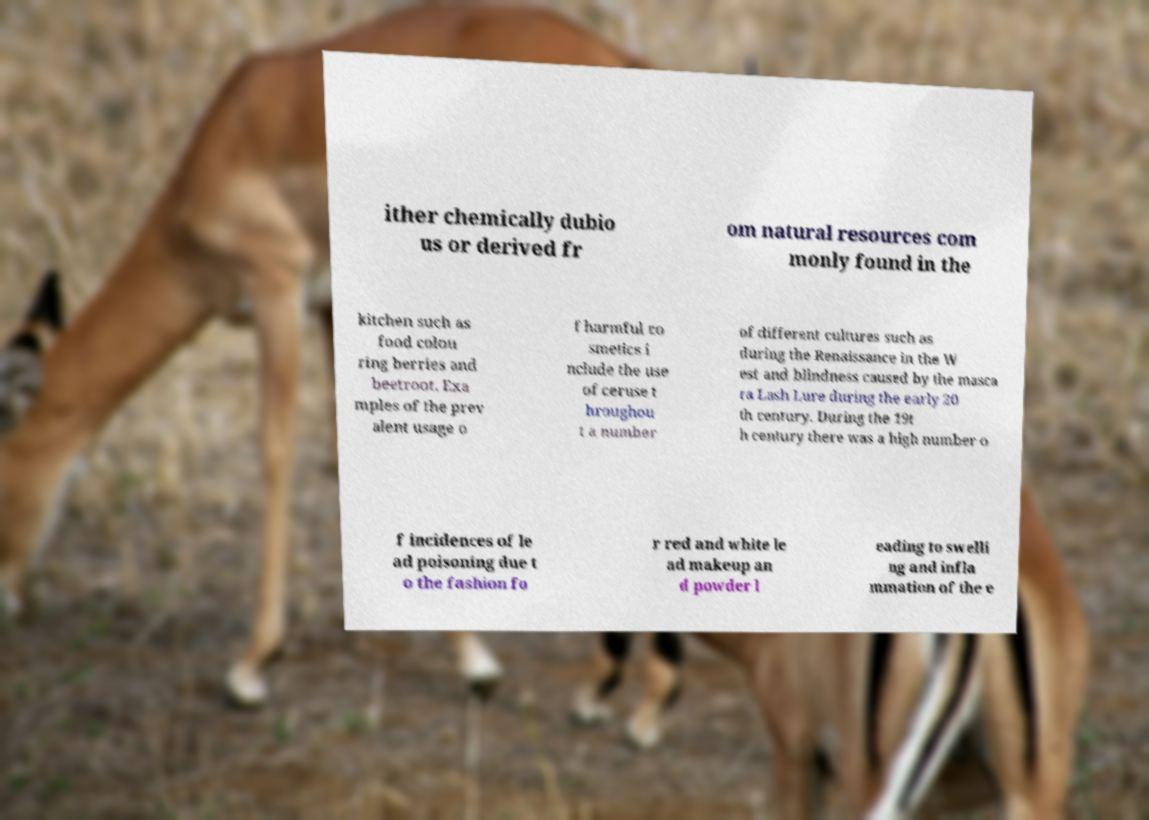Can you accurately transcribe the text from the provided image for me? ither chemically dubio us or derived fr om natural resources com monly found in the kitchen such as food colou ring berries and beetroot. Exa mples of the prev alent usage o f harmful co smetics i nclude the use of ceruse t hroughou t a number of different cultures such as during the Renaissance in the W est and blindness caused by the masca ra Lash Lure during the early 20 th century. During the 19t h century there was a high number o f incidences of le ad poisoning due t o the fashion fo r red and white le ad makeup an d powder l eading to swelli ng and infla mmation of the e 